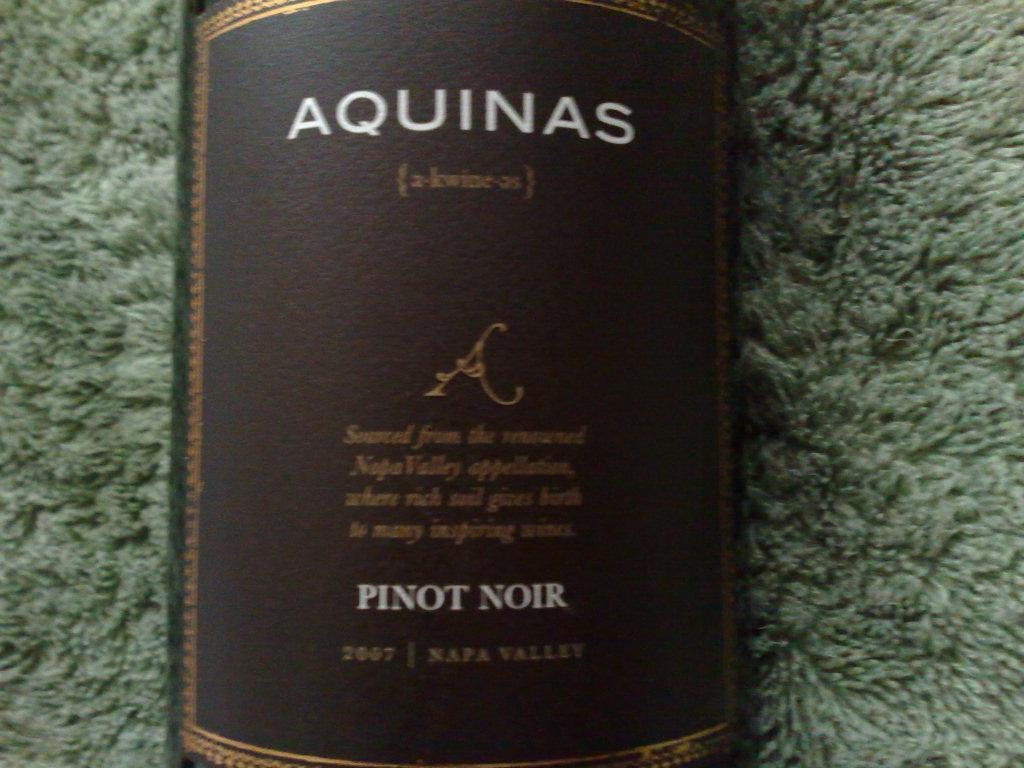<image>
Provide a brief description of the given image. A label on a bottle of Aquinas Pinot Noir. 